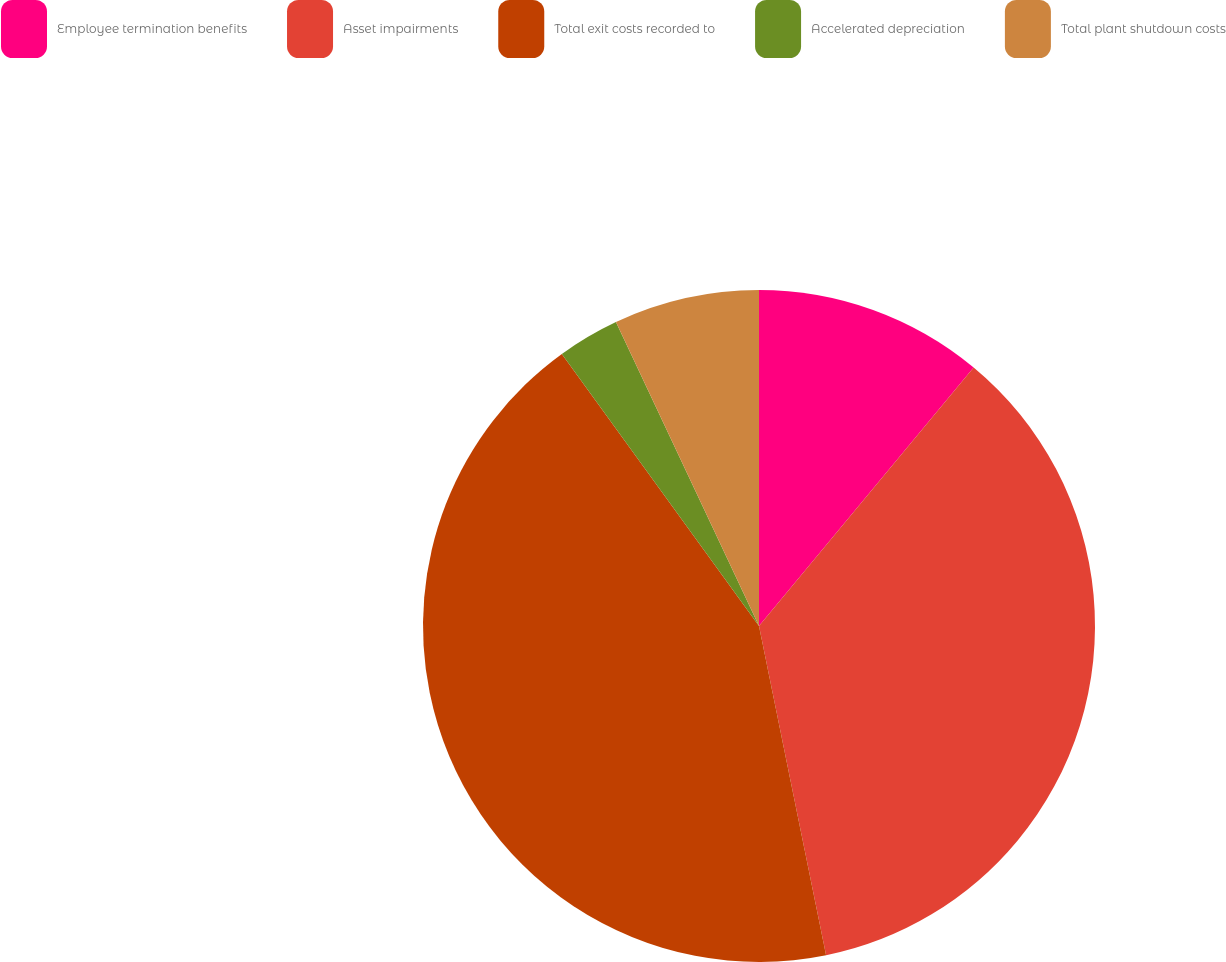Convert chart to OTSL. <chart><loc_0><loc_0><loc_500><loc_500><pie_chart><fcel>Employee termination benefits<fcel>Asset impairments<fcel>Total exit costs recorded to<fcel>Accelerated depreciation<fcel>Total plant shutdown costs<nl><fcel>11.03%<fcel>35.77%<fcel>43.22%<fcel>2.98%<fcel>7.0%<nl></chart> 